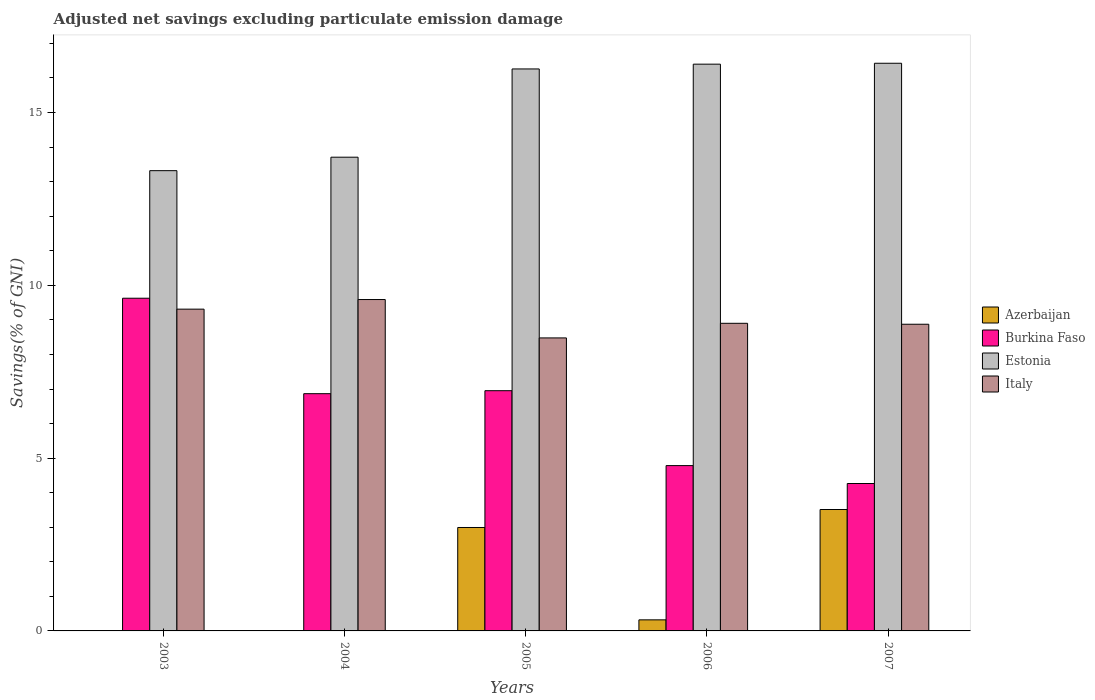Are the number of bars per tick equal to the number of legend labels?
Ensure brevity in your answer.  No. Are the number of bars on each tick of the X-axis equal?
Provide a short and direct response. No. What is the adjusted net savings in Estonia in 2006?
Your answer should be compact. 16.4. Across all years, what is the maximum adjusted net savings in Burkina Faso?
Keep it short and to the point. 9.63. In which year was the adjusted net savings in Estonia maximum?
Offer a terse response. 2007. What is the total adjusted net savings in Azerbaijan in the graph?
Provide a succinct answer. 6.83. What is the difference between the adjusted net savings in Burkina Faso in 2003 and that in 2005?
Make the answer very short. 2.68. What is the difference between the adjusted net savings in Burkina Faso in 2005 and the adjusted net savings in Estonia in 2003?
Provide a short and direct response. -6.37. What is the average adjusted net savings in Estonia per year?
Your answer should be compact. 15.22. In the year 2003, what is the difference between the adjusted net savings in Italy and adjusted net savings in Burkina Faso?
Provide a succinct answer. -0.32. What is the ratio of the adjusted net savings in Italy in 2003 to that in 2007?
Your answer should be very brief. 1.05. Is the difference between the adjusted net savings in Italy in 2005 and 2006 greater than the difference between the adjusted net savings in Burkina Faso in 2005 and 2006?
Keep it short and to the point. No. What is the difference between the highest and the second highest adjusted net savings in Burkina Faso?
Give a very brief answer. 2.68. What is the difference between the highest and the lowest adjusted net savings in Burkina Faso?
Your answer should be compact. 5.36. Is the sum of the adjusted net savings in Italy in 2003 and 2004 greater than the maximum adjusted net savings in Burkina Faso across all years?
Your answer should be compact. Yes. Is it the case that in every year, the sum of the adjusted net savings in Italy and adjusted net savings in Burkina Faso is greater than the sum of adjusted net savings in Estonia and adjusted net savings in Azerbaijan?
Your response must be concise. Yes. Is it the case that in every year, the sum of the adjusted net savings in Burkina Faso and adjusted net savings in Azerbaijan is greater than the adjusted net savings in Estonia?
Keep it short and to the point. No. How many bars are there?
Your answer should be very brief. 18. How many years are there in the graph?
Your response must be concise. 5. What is the difference between two consecutive major ticks on the Y-axis?
Your answer should be very brief. 5. Are the values on the major ticks of Y-axis written in scientific E-notation?
Your answer should be compact. No. Does the graph contain any zero values?
Ensure brevity in your answer.  Yes. Does the graph contain grids?
Your answer should be compact. No. Where does the legend appear in the graph?
Offer a terse response. Center right. How many legend labels are there?
Keep it short and to the point. 4. How are the legend labels stacked?
Provide a short and direct response. Vertical. What is the title of the graph?
Your answer should be compact. Adjusted net savings excluding particulate emission damage. What is the label or title of the X-axis?
Offer a terse response. Years. What is the label or title of the Y-axis?
Make the answer very short. Savings(% of GNI). What is the Savings(% of GNI) in Azerbaijan in 2003?
Your answer should be very brief. 0. What is the Savings(% of GNI) in Burkina Faso in 2003?
Provide a succinct answer. 9.63. What is the Savings(% of GNI) in Estonia in 2003?
Ensure brevity in your answer.  13.32. What is the Savings(% of GNI) of Italy in 2003?
Offer a terse response. 9.31. What is the Savings(% of GNI) in Azerbaijan in 2004?
Keep it short and to the point. 0. What is the Savings(% of GNI) of Burkina Faso in 2004?
Keep it short and to the point. 6.86. What is the Savings(% of GNI) of Estonia in 2004?
Keep it short and to the point. 13.71. What is the Savings(% of GNI) of Italy in 2004?
Provide a short and direct response. 9.59. What is the Savings(% of GNI) in Azerbaijan in 2005?
Your answer should be very brief. 2.99. What is the Savings(% of GNI) of Burkina Faso in 2005?
Provide a succinct answer. 6.95. What is the Savings(% of GNI) of Estonia in 2005?
Provide a succinct answer. 16.26. What is the Savings(% of GNI) of Italy in 2005?
Give a very brief answer. 8.48. What is the Savings(% of GNI) of Azerbaijan in 2006?
Give a very brief answer. 0.32. What is the Savings(% of GNI) in Burkina Faso in 2006?
Offer a very short reply. 4.78. What is the Savings(% of GNI) of Estonia in 2006?
Make the answer very short. 16.4. What is the Savings(% of GNI) in Italy in 2006?
Ensure brevity in your answer.  8.9. What is the Savings(% of GNI) of Azerbaijan in 2007?
Your answer should be compact. 3.51. What is the Savings(% of GNI) of Burkina Faso in 2007?
Your answer should be very brief. 4.27. What is the Savings(% of GNI) in Estonia in 2007?
Provide a short and direct response. 16.43. What is the Savings(% of GNI) in Italy in 2007?
Your answer should be very brief. 8.87. Across all years, what is the maximum Savings(% of GNI) of Azerbaijan?
Make the answer very short. 3.51. Across all years, what is the maximum Savings(% of GNI) in Burkina Faso?
Ensure brevity in your answer.  9.63. Across all years, what is the maximum Savings(% of GNI) in Estonia?
Provide a short and direct response. 16.43. Across all years, what is the maximum Savings(% of GNI) in Italy?
Make the answer very short. 9.59. Across all years, what is the minimum Savings(% of GNI) in Azerbaijan?
Your response must be concise. 0. Across all years, what is the minimum Savings(% of GNI) in Burkina Faso?
Offer a very short reply. 4.27. Across all years, what is the minimum Savings(% of GNI) of Estonia?
Offer a very short reply. 13.32. Across all years, what is the minimum Savings(% of GNI) of Italy?
Offer a very short reply. 8.48. What is the total Savings(% of GNI) of Azerbaijan in the graph?
Your answer should be compact. 6.83. What is the total Savings(% of GNI) in Burkina Faso in the graph?
Your answer should be compact. 32.49. What is the total Savings(% of GNI) of Estonia in the graph?
Offer a terse response. 76.11. What is the total Savings(% of GNI) of Italy in the graph?
Keep it short and to the point. 45.15. What is the difference between the Savings(% of GNI) in Burkina Faso in 2003 and that in 2004?
Keep it short and to the point. 2.76. What is the difference between the Savings(% of GNI) in Estonia in 2003 and that in 2004?
Offer a very short reply. -0.39. What is the difference between the Savings(% of GNI) of Italy in 2003 and that in 2004?
Your answer should be very brief. -0.28. What is the difference between the Savings(% of GNI) in Burkina Faso in 2003 and that in 2005?
Provide a succinct answer. 2.68. What is the difference between the Savings(% of GNI) of Estonia in 2003 and that in 2005?
Keep it short and to the point. -2.94. What is the difference between the Savings(% of GNI) in Italy in 2003 and that in 2005?
Keep it short and to the point. 0.83. What is the difference between the Savings(% of GNI) in Burkina Faso in 2003 and that in 2006?
Give a very brief answer. 4.84. What is the difference between the Savings(% of GNI) in Estonia in 2003 and that in 2006?
Your answer should be compact. -3.08. What is the difference between the Savings(% of GNI) in Italy in 2003 and that in 2006?
Keep it short and to the point. 0.41. What is the difference between the Savings(% of GNI) in Burkina Faso in 2003 and that in 2007?
Your answer should be compact. 5.36. What is the difference between the Savings(% of GNI) of Estonia in 2003 and that in 2007?
Ensure brevity in your answer.  -3.11. What is the difference between the Savings(% of GNI) of Italy in 2003 and that in 2007?
Ensure brevity in your answer.  0.44. What is the difference between the Savings(% of GNI) in Burkina Faso in 2004 and that in 2005?
Provide a short and direct response. -0.09. What is the difference between the Savings(% of GNI) of Estonia in 2004 and that in 2005?
Your answer should be very brief. -2.55. What is the difference between the Savings(% of GNI) in Italy in 2004 and that in 2005?
Offer a terse response. 1.11. What is the difference between the Savings(% of GNI) in Burkina Faso in 2004 and that in 2006?
Provide a succinct answer. 2.08. What is the difference between the Savings(% of GNI) of Estonia in 2004 and that in 2006?
Provide a succinct answer. -2.69. What is the difference between the Savings(% of GNI) of Italy in 2004 and that in 2006?
Make the answer very short. 0.69. What is the difference between the Savings(% of GNI) of Burkina Faso in 2004 and that in 2007?
Ensure brevity in your answer.  2.6. What is the difference between the Savings(% of GNI) in Estonia in 2004 and that in 2007?
Provide a short and direct response. -2.72. What is the difference between the Savings(% of GNI) in Italy in 2004 and that in 2007?
Ensure brevity in your answer.  0.71. What is the difference between the Savings(% of GNI) in Azerbaijan in 2005 and that in 2006?
Your response must be concise. 2.67. What is the difference between the Savings(% of GNI) in Burkina Faso in 2005 and that in 2006?
Your response must be concise. 2.17. What is the difference between the Savings(% of GNI) of Estonia in 2005 and that in 2006?
Offer a very short reply. -0.14. What is the difference between the Savings(% of GNI) in Italy in 2005 and that in 2006?
Your answer should be very brief. -0.42. What is the difference between the Savings(% of GNI) in Azerbaijan in 2005 and that in 2007?
Offer a very short reply. -0.52. What is the difference between the Savings(% of GNI) in Burkina Faso in 2005 and that in 2007?
Your response must be concise. 2.69. What is the difference between the Savings(% of GNI) of Estonia in 2005 and that in 2007?
Provide a succinct answer. -0.16. What is the difference between the Savings(% of GNI) of Italy in 2005 and that in 2007?
Your answer should be compact. -0.4. What is the difference between the Savings(% of GNI) in Azerbaijan in 2006 and that in 2007?
Your answer should be very brief. -3.19. What is the difference between the Savings(% of GNI) of Burkina Faso in 2006 and that in 2007?
Your response must be concise. 0.52. What is the difference between the Savings(% of GNI) in Estonia in 2006 and that in 2007?
Your response must be concise. -0.03. What is the difference between the Savings(% of GNI) in Italy in 2006 and that in 2007?
Offer a very short reply. 0.03. What is the difference between the Savings(% of GNI) in Burkina Faso in 2003 and the Savings(% of GNI) in Estonia in 2004?
Give a very brief answer. -4.08. What is the difference between the Savings(% of GNI) of Burkina Faso in 2003 and the Savings(% of GNI) of Italy in 2004?
Keep it short and to the point. 0.04. What is the difference between the Savings(% of GNI) of Estonia in 2003 and the Savings(% of GNI) of Italy in 2004?
Ensure brevity in your answer.  3.73. What is the difference between the Savings(% of GNI) in Burkina Faso in 2003 and the Savings(% of GNI) in Estonia in 2005?
Your response must be concise. -6.63. What is the difference between the Savings(% of GNI) of Burkina Faso in 2003 and the Savings(% of GNI) of Italy in 2005?
Your response must be concise. 1.15. What is the difference between the Savings(% of GNI) of Estonia in 2003 and the Savings(% of GNI) of Italy in 2005?
Ensure brevity in your answer.  4.84. What is the difference between the Savings(% of GNI) of Burkina Faso in 2003 and the Savings(% of GNI) of Estonia in 2006?
Your response must be concise. -6.77. What is the difference between the Savings(% of GNI) in Burkina Faso in 2003 and the Savings(% of GNI) in Italy in 2006?
Offer a terse response. 0.73. What is the difference between the Savings(% of GNI) of Estonia in 2003 and the Savings(% of GNI) of Italy in 2006?
Offer a terse response. 4.42. What is the difference between the Savings(% of GNI) of Burkina Faso in 2003 and the Savings(% of GNI) of Estonia in 2007?
Give a very brief answer. -6.8. What is the difference between the Savings(% of GNI) of Burkina Faso in 2003 and the Savings(% of GNI) of Italy in 2007?
Make the answer very short. 0.75. What is the difference between the Savings(% of GNI) of Estonia in 2003 and the Savings(% of GNI) of Italy in 2007?
Offer a very short reply. 4.44. What is the difference between the Savings(% of GNI) in Burkina Faso in 2004 and the Savings(% of GNI) in Estonia in 2005?
Provide a short and direct response. -9.4. What is the difference between the Savings(% of GNI) in Burkina Faso in 2004 and the Savings(% of GNI) in Italy in 2005?
Offer a very short reply. -1.61. What is the difference between the Savings(% of GNI) of Estonia in 2004 and the Savings(% of GNI) of Italy in 2005?
Make the answer very short. 5.23. What is the difference between the Savings(% of GNI) of Burkina Faso in 2004 and the Savings(% of GNI) of Estonia in 2006?
Offer a terse response. -9.53. What is the difference between the Savings(% of GNI) in Burkina Faso in 2004 and the Savings(% of GNI) in Italy in 2006?
Your answer should be very brief. -2.04. What is the difference between the Savings(% of GNI) of Estonia in 2004 and the Savings(% of GNI) of Italy in 2006?
Your response must be concise. 4.81. What is the difference between the Savings(% of GNI) in Burkina Faso in 2004 and the Savings(% of GNI) in Estonia in 2007?
Make the answer very short. -9.56. What is the difference between the Savings(% of GNI) in Burkina Faso in 2004 and the Savings(% of GNI) in Italy in 2007?
Ensure brevity in your answer.  -2.01. What is the difference between the Savings(% of GNI) of Estonia in 2004 and the Savings(% of GNI) of Italy in 2007?
Your answer should be very brief. 4.83. What is the difference between the Savings(% of GNI) in Azerbaijan in 2005 and the Savings(% of GNI) in Burkina Faso in 2006?
Offer a terse response. -1.79. What is the difference between the Savings(% of GNI) of Azerbaijan in 2005 and the Savings(% of GNI) of Estonia in 2006?
Provide a short and direct response. -13.41. What is the difference between the Savings(% of GNI) in Azerbaijan in 2005 and the Savings(% of GNI) in Italy in 2006?
Give a very brief answer. -5.91. What is the difference between the Savings(% of GNI) of Burkina Faso in 2005 and the Savings(% of GNI) of Estonia in 2006?
Ensure brevity in your answer.  -9.45. What is the difference between the Savings(% of GNI) in Burkina Faso in 2005 and the Savings(% of GNI) in Italy in 2006?
Your answer should be compact. -1.95. What is the difference between the Savings(% of GNI) in Estonia in 2005 and the Savings(% of GNI) in Italy in 2006?
Provide a succinct answer. 7.36. What is the difference between the Savings(% of GNI) in Azerbaijan in 2005 and the Savings(% of GNI) in Burkina Faso in 2007?
Your answer should be compact. -1.27. What is the difference between the Savings(% of GNI) of Azerbaijan in 2005 and the Savings(% of GNI) of Estonia in 2007?
Your answer should be very brief. -13.43. What is the difference between the Savings(% of GNI) of Azerbaijan in 2005 and the Savings(% of GNI) of Italy in 2007?
Offer a terse response. -5.88. What is the difference between the Savings(% of GNI) of Burkina Faso in 2005 and the Savings(% of GNI) of Estonia in 2007?
Keep it short and to the point. -9.47. What is the difference between the Savings(% of GNI) of Burkina Faso in 2005 and the Savings(% of GNI) of Italy in 2007?
Offer a terse response. -1.92. What is the difference between the Savings(% of GNI) of Estonia in 2005 and the Savings(% of GNI) of Italy in 2007?
Provide a succinct answer. 7.39. What is the difference between the Savings(% of GNI) of Azerbaijan in 2006 and the Savings(% of GNI) of Burkina Faso in 2007?
Keep it short and to the point. -3.95. What is the difference between the Savings(% of GNI) of Azerbaijan in 2006 and the Savings(% of GNI) of Estonia in 2007?
Provide a succinct answer. -16.11. What is the difference between the Savings(% of GNI) in Azerbaijan in 2006 and the Savings(% of GNI) in Italy in 2007?
Provide a succinct answer. -8.55. What is the difference between the Savings(% of GNI) in Burkina Faso in 2006 and the Savings(% of GNI) in Estonia in 2007?
Your answer should be very brief. -11.64. What is the difference between the Savings(% of GNI) of Burkina Faso in 2006 and the Savings(% of GNI) of Italy in 2007?
Your response must be concise. -4.09. What is the difference between the Savings(% of GNI) of Estonia in 2006 and the Savings(% of GNI) of Italy in 2007?
Keep it short and to the point. 7.53. What is the average Savings(% of GNI) in Azerbaijan per year?
Offer a terse response. 1.37. What is the average Savings(% of GNI) of Burkina Faso per year?
Give a very brief answer. 6.5. What is the average Savings(% of GNI) of Estonia per year?
Ensure brevity in your answer.  15.22. What is the average Savings(% of GNI) of Italy per year?
Your answer should be compact. 9.03. In the year 2003, what is the difference between the Savings(% of GNI) in Burkina Faso and Savings(% of GNI) in Estonia?
Keep it short and to the point. -3.69. In the year 2003, what is the difference between the Savings(% of GNI) of Burkina Faso and Savings(% of GNI) of Italy?
Offer a terse response. 0.32. In the year 2003, what is the difference between the Savings(% of GNI) in Estonia and Savings(% of GNI) in Italy?
Keep it short and to the point. 4.01. In the year 2004, what is the difference between the Savings(% of GNI) of Burkina Faso and Savings(% of GNI) of Estonia?
Ensure brevity in your answer.  -6.84. In the year 2004, what is the difference between the Savings(% of GNI) of Burkina Faso and Savings(% of GNI) of Italy?
Your response must be concise. -2.72. In the year 2004, what is the difference between the Savings(% of GNI) in Estonia and Savings(% of GNI) in Italy?
Your answer should be very brief. 4.12. In the year 2005, what is the difference between the Savings(% of GNI) of Azerbaijan and Savings(% of GNI) of Burkina Faso?
Offer a terse response. -3.96. In the year 2005, what is the difference between the Savings(% of GNI) in Azerbaijan and Savings(% of GNI) in Estonia?
Your response must be concise. -13.27. In the year 2005, what is the difference between the Savings(% of GNI) in Azerbaijan and Savings(% of GNI) in Italy?
Your response must be concise. -5.49. In the year 2005, what is the difference between the Savings(% of GNI) in Burkina Faso and Savings(% of GNI) in Estonia?
Make the answer very short. -9.31. In the year 2005, what is the difference between the Savings(% of GNI) of Burkina Faso and Savings(% of GNI) of Italy?
Your answer should be compact. -1.53. In the year 2005, what is the difference between the Savings(% of GNI) of Estonia and Savings(% of GNI) of Italy?
Your answer should be very brief. 7.78. In the year 2006, what is the difference between the Savings(% of GNI) in Azerbaijan and Savings(% of GNI) in Burkina Faso?
Provide a short and direct response. -4.46. In the year 2006, what is the difference between the Savings(% of GNI) of Azerbaijan and Savings(% of GNI) of Estonia?
Offer a very short reply. -16.08. In the year 2006, what is the difference between the Savings(% of GNI) of Azerbaijan and Savings(% of GNI) of Italy?
Give a very brief answer. -8.58. In the year 2006, what is the difference between the Savings(% of GNI) of Burkina Faso and Savings(% of GNI) of Estonia?
Provide a succinct answer. -11.62. In the year 2006, what is the difference between the Savings(% of GNI) of Burkina Faso and Savings(% of GNI) of Italy?
Keep it short and to the point. -4.12. In the year 2006, what is the difference between the Savings(% of GNI) in Estonia and Savings(% of GNI) in Italy?
Ensure brevity in your answer.  7.5. In the year 2007, what is the difference between the Savings(% of GNI) of Azerbaijan and Savings(% of GNI) of Burkina Faso?
Provide a short and direct response. -0.75. In the year 2007, what is the difference between the Savings(% of GNI) of Azerbaijan and Savings(% of GNI) of Estonia?
Provide a succinct answer. -12.91. In the year 2007, what is the difference between the Savings(% of GNI) in Azerbaijan and Savings(% of GNI) in Italy?
Provide a short and direct response. -5.36. In the year 2007, what is the difference between the Savings(% of GNI) of Burkina Faso and Savings(% of GNI) of Estonia?
Keep it short and to the point. -12.16. In the year 2007, what is the difference between the Savings(% of GNI) in Burkina Faso and Savings(% of GNI) in Italy?
Your response must be concise. -4.61. In the year 2007, what is the difference between the Savings(% of GNI) in Estonia and Savings(% of GNI) in Italy?
Offer a very short reply. 7.55. What is the ratio of the Savings(% of GNI) in Burkina Faso in 2003 to that in 2004?
Keep it short and to the point. 1.4. What is the ratio of the Savings(% of GNI) in Estonia in 2003 to that in 2004?
Offer a terse response. 0.97. What is the ratio of the Savings(% of GNI) in Burkina Faso in 2003 to that in 2005?
Your answer should be very brief. 1.39. What is the ratio of the Savings(% of GNI) in Estonia in 2003 to that in 2005?
Ensure brevity in your answer.  0.82. What is the ratio of the Savings(% of GNI) in Italy in 2003 to that in 2005?
Offer a very short reply. 1.1. What is the ratio of the Savings(% of GNI) in Burkina Faso in 2003 to that in 2006?
Keep it short and to the point. 2.01. What is the ratio of the Savings(% of GNI) of Estonia in 2003 to that in 2006?
Make the answer very short. 0.81. What is the ratio of the Savings(% of GNI) in Italy in 2003 to that in 2006?
Provide a succinct answer. 1.05. What is the ratio of the Savings(% of GNI) in Burkina Faso in 2003 to that in 2007?
Your answer should be very brief. 2.26. What is the ratio of the Savings(% of GNI) of Estonia in 2003 to that in 2007?
Your response must be concise. 0.81. What is the ratio of the Savings(% of GNI) in Italy in 2003 to that in 2007?
Offer a terse response. 1.05. What is the ratio of the Savings(% of GNI) of Burkina Faso in 2004 to that in 2005?
Give a very brief answer. 0.99. What is the ratio of the Savings(% of GNI) of Estonia in 2004 to that in 2005?
Your answer should be very brief. 0.84. What is the ratio of the Savings(% of GNI) of Italy in 2004 to that in 2005?
Make the answer very short. 1.13. What is the ratio of the Savings(% of GNI) in Burkina Faso in 2004 to that in 2006?
Your answer should be compact. 1.44. What is the ratio of the Savings(% of GNI) of Estonia in 2004 to that in 2006?
Your answer should be compact. 0.84. What is the ratio of the Savings(% of GNI) of Italy in 2004 to that in 2006?
Your answer should be very brief. 1.08. What is the ratio of the Savings(% of GNI) of Burkina Faso in 2004 to that in 2007?
Keep it short and to the point. 1.61. What is the ratio of the Savings(% of GNI) of Estonia in 2004 to that in 2007?
Keep it short and to the point. 0.83. What is the ratio of the Savings(% of GNI) in Italy in 2004 to that in 2007?
Offer a very short reply. 1.08. What is the ratio of the Savings(% of GNI) in Azerbaijan in 2005 to that in 2006?
Your answer should be very brief. 9.34. What is the ratio of the Savings(% of GNI) of Burkina Faso in 2005 to that in 2006?
Provide a succinct answer. 1.45. What is the ratio of the Savings(% of GNI) of Estonia in 2005 to that in 2006?
Your response must be concise. 0.99. What is the ratio of the Savings(% of GNI) of Italy in 2005 to that in 2006?
Your answer should be compact. 0.95. What is the ratio of the Savings(% of GNI) of Azerbaijan in 2005 to that in 2007?
Offer a very short reply. 0.85. What is the ratio of the Savings(% of GNI) in Burkina Faso in 2005 to that in 2007?
Offer a very short reply. 1.63. What is the ratio of the Savings(% of GNI) of Estonia in 2005 to that in 2007?
Provide a short and direct response. 0.99. What is the ratio of the Savings(% of GNI) in Italy in 2005 to that in 2007?
Your response must be concise. 0.96. What is the ratio of the Savings(% of GNI) of Azerbaijan in 2006 to that in 2007?
Your answer should be compact. 0.09. What is the ratio of the Savings(% of GNI) in Burkina Faso in 2006 to that in 2007?
Ensure brevity in your answer.  1.12. What is the ratio of the Savings(% of GNI) in Estonia in 2006 to that in 2007?
Provide a short and direct response. 1. What is the ratio of the Savings(% of GNI) of Italy in 2006 to that in 2007?
Provide a short and direct response. 1. What is the difference between the highest and the second highest Savings(% of GNI) of Azerbaijan?
Your answer should be compact. 0.52. What is the difference between the highest and the second highest Savings(% of GNI) in Burkina Faso?
Your answer should be compact. 2.68. What is the difference between the highest and the second highest Savings(% of GNI) of Estonia?
Your response must be concise. 0.03. What is the difference between the highest and the second highest Savings(% of GNI) of Italy?
Your answer should be very brief. 0.28. What is the difference between the highest and the lowest Savings(% of GNI) of Azerbaijan?
Your answer should be compact. 3.51. What is the difference between the highest and the lowest Savings(% of GNI) in Burkina Faso?
Offer a very short reply. 5.36. What is the difference between the highest and the lowest Savings(% of GNI) in Estonia?
Keep it short and to the point. 3.11. What is the difference between the highest and the lowest Savings(% of GNI) in Italy?
Make the answer very short. 1.11. 